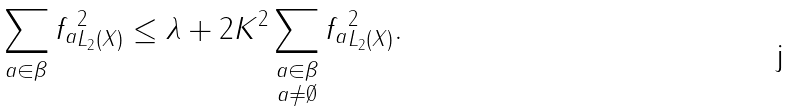<formula> <loc_0><loc_0><loc_500><loc_500>\| \sum _ { a \in \beta } f _ { a } \| ^ { 2 } _ { L _ { 2 } ( X ) } \leq \lambda + 2 K ^ { 2 } \sum _ { \substack { a \in \beta \\ a \neq \emptyset } } \| f _ { a } \| ^ { 2 } _ { L _ { 2 } ( X ) } .</formula> 